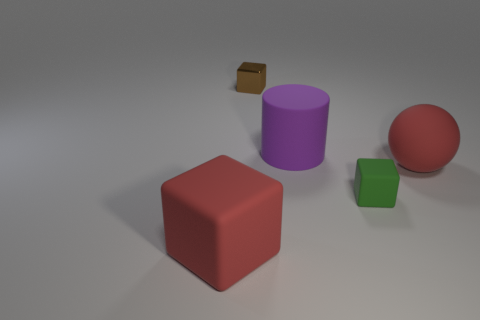What color is the rubber ball? The rubber ball in the image is a vivid red, reminiscent of ripe cherries or a stop sign, capturing your attention immediately with its glossy finish. 